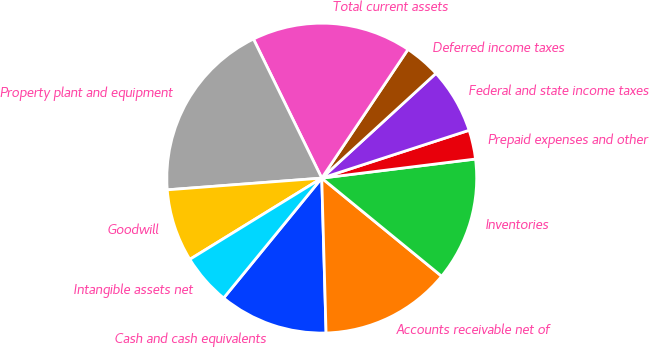<chart> <loc_0><loc_0><loc_500><loc_500><pie_chart><fcel>Cash and cash equivalents<fcel>Accounts receivable net of<fcel>Inventories<fcel>Prepaid expenses and other<fcel>Federal and state income taxes<fcel>Deferred income taxes<fcel>Total current assets<fcel>Property plant and equipment<fcel>Goodwill<fcel>Intangible assets net<nl><fcel>11.36%<fcel>13.64%<fcel>12.88%<fcel>3.03%<fcel>6.82%<fcel>3.79%<fcel>16.66%<fcel>18.94%<fcel>7.58%<fcel>5.3%<nl></chart> 